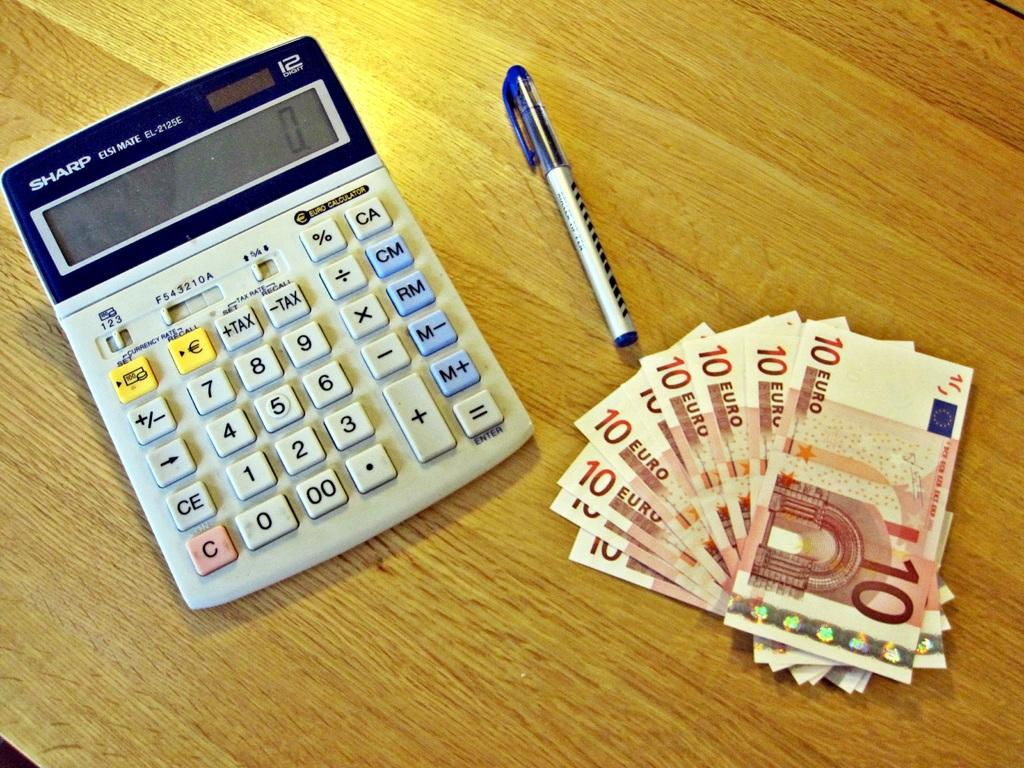<image>
Offer a succinct explanation of the picture presented. A calculator, pen and many euros labeled 10. 